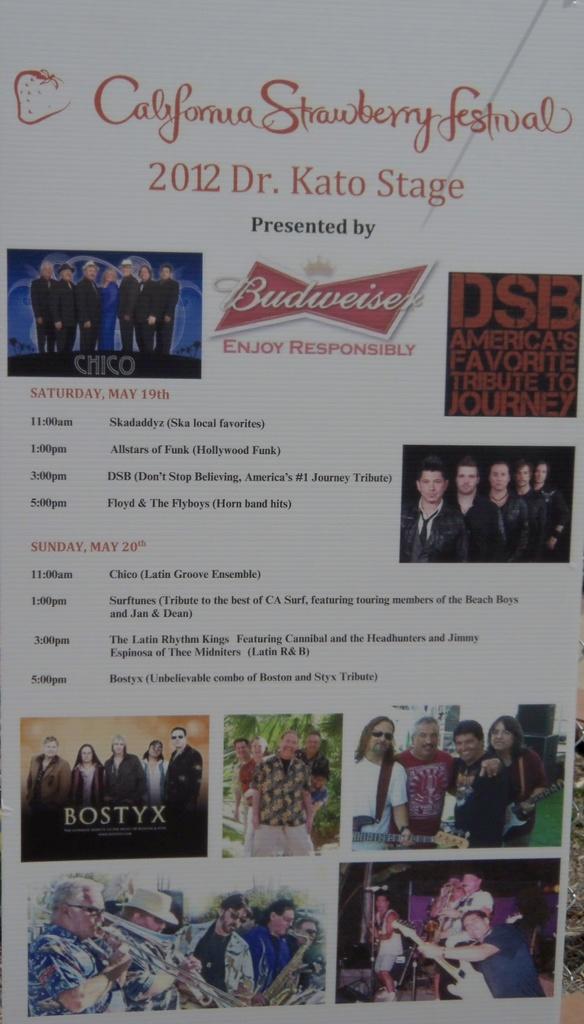What beer company is sponsoring this event?
Provide a succinct answer. Budweiser. What festival is being advertised?
Give a very brief answer. California strawberry festival. 